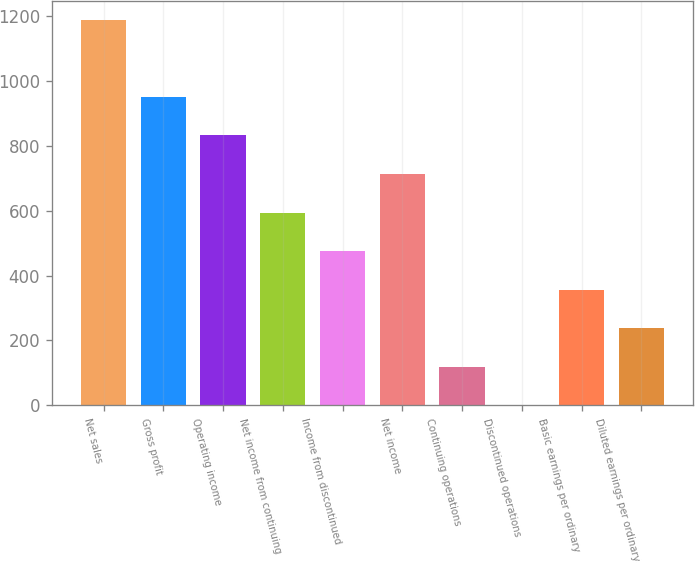Convert chart to OTSL. <chart><loc_0><loc_0><loc_500><loc_500><bar_chart><fcel>Net sales<fcel>Gross profit<fcel>Operating income<fcel>Net income from continuing<fcel>Income from discontinued<fcel>Net income<fcel>Continuing operations<fcel>Discontinued operations<fcel>Basic earnings per ordinary<fcel>Diluted earnings per ordinary<nl><fcel>1188.1<fcel>950.52<fcel>831.72<fcel>594.12<fcel>475.32<fcel>712.92<fcel>118.92<fcel>0.12<fcel>356.52<fcel>237.72<nl></chart> 